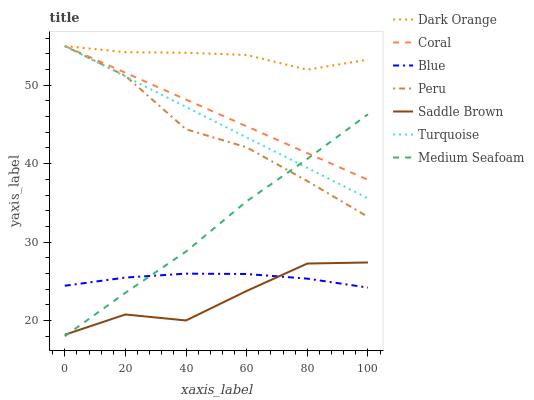Does Saddle Brown have the minimum area under the curve?
Answer yes or no. Yes. Does Dark Orange have the maximum area under the curve?
Answer yes or no. Yes. Does Turquoise have the minimum area under the curve?
Answer yes or no. No. Does Turquoise have the maximum area under the curve?
Answer yes or no. No. Is Turquoise the smoothest?
Answer yes or no. Yes. Is Saddle Brown the roughest?
Answer yes or no. Yes. Is Dark Orange the smoothest?
Answer yes or no. No. Is Dark Orange the roughest?
Answer yes or no. No. Does Turquoise have the lowest value?
Answer yes or no. No. Does Peru have the highest value?
Answer yes or no. Yes. Does Medium Seafoam have the highest value?
Answer yes or no. No. Is Blue less than Peru?
Answer yes or no. Yes. Is Coral greater than Saddle Brown?
Answer yes or no. Yes. Does Blue intersect Saddle Brown?
Answer yes or no. Yes. Is Blue less than Saddle Brown?
Answer yes or no. No. Is Blue greater than Saddle Brown?
Answer yes or no. No. Does Blue intersect Peru?
Answer yes or no. No. 